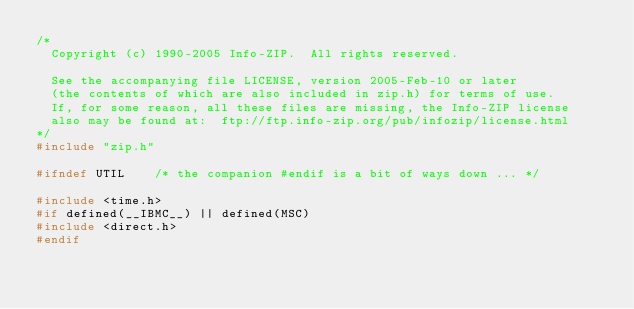Convert code to text. <code><loc_0><loc_0><loc_500><loc_500><_C_>/*
  Copyright (c) 1990-2005 Info-ZIP.  All rights reserved.

  See the accompanying file LICENSE, version 2005-Feb-10 or later
  (the contents of which are also included in zip.h) for terms of use.
  If, for some reason, all these files are missing, the Info-ZIP license
  also may be found at:  ftp://ftp.info-zip.org/pub/infozip/license.html
*/
#include "zip.h"

#ifndef UTIL    /* the companion #endif is a bit of ways down ... */

#include <time.h>
#if defined(__IBMC__) || defined(MSC)
#include <direct.h>
#endif
</code> 